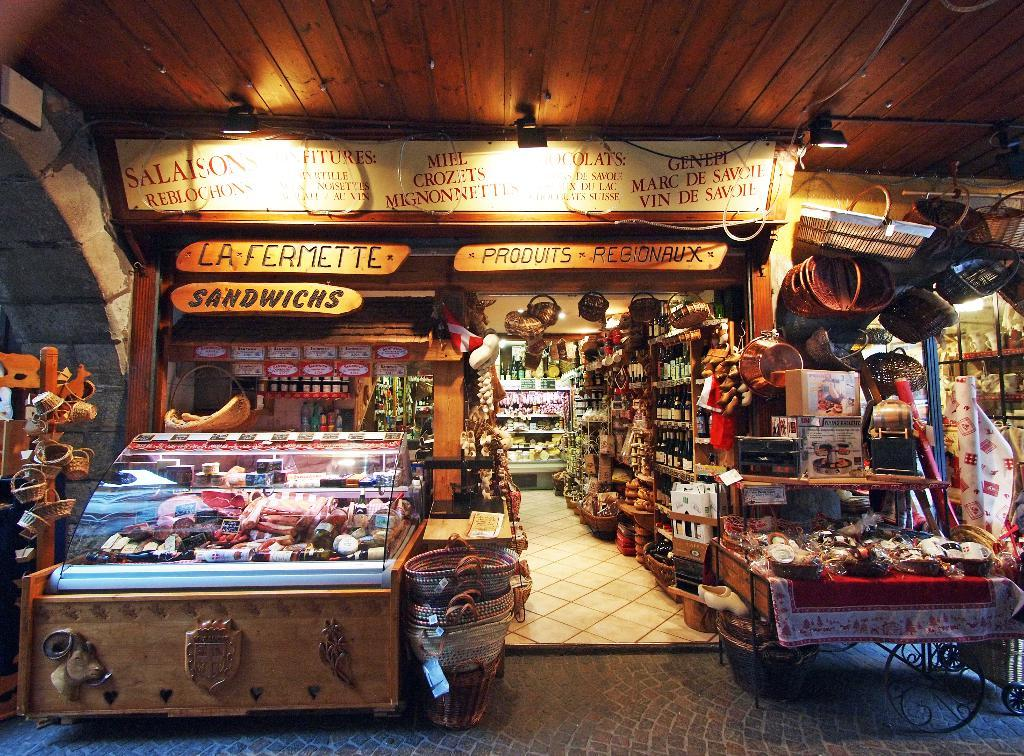Provide a one-sentence caption for the provided image. A store has signs that read la fermette, sandwichs, and produits regionbux. 